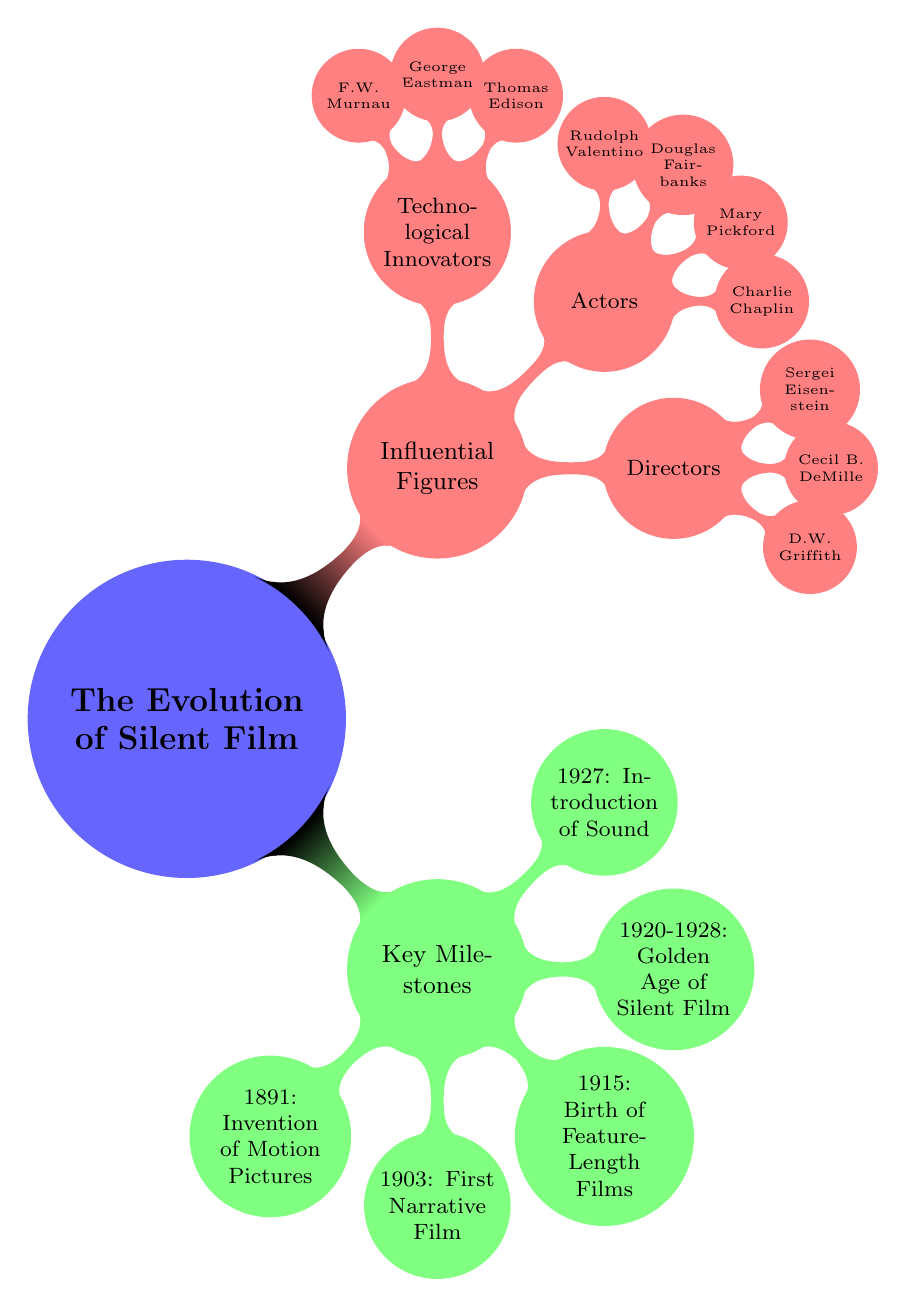What year did the invention of motion pictures occur? The mind map states the invention of motion pictures occurred in 1891 under the key milestones section.
Answer: 1891 Who directed the first narrative film? According to the diagram, the first narrative film, "The Great Train Robbery," was directed by Edwin S. Porter.
Answer: Edwin S. Porter What were the notable films during the Golden Age of Silent Film? The diagram lists "The Cabinet of Dr. Caligari (1920)" and "Metropolis (1927)" as notable films during the Golden Age of Silent Film.
Answer: The Cabinet of Dr. Caligari, Metropolis Which director is known for the film "The Birth of a Nation"? The diagram indicates that D.W. Griffith directed the film "The Birth of a Nation" in 1915, highlighting his significance in the timeline.
Answer: D.W. Griffith How many actors are listed in the Influential Figures section? By counting the actors listed under the Influential Figures node, we find there are four actors mentioned: Charlie Chaplin, Mary Pickford, Douglas Fairbanks, and Rudolph Valentino.
Answer: 4 Which milestone indicates the transition to sound in film? The diagram specifies that the introduction of sound in film was marked by "The Jazz Singer," released in 1927, highlighting a significant transition in film history.
Answer: Introduction of Sound What is the span of years associated with the Golden Age of Silent Film? As shown in the diagram, the Golden Age of Silent Film is represented by the years 1920 to 1928.
Answer: 1920-1928 Who is considered a technological innovator in silent film history? The diagram categorizes Thomas Edison, George Eastman, and F.W. Murnau as technological innovators, signifying their contributions to the film industry.
Answer: Thomas Edison What type of film was "The Birth of a Nation"? The timeline indicates "The Birth of a Nation" is recognized as the birth of feature-length films, which denotes its significance in film evolution.
Answer: Feature-Length Film 